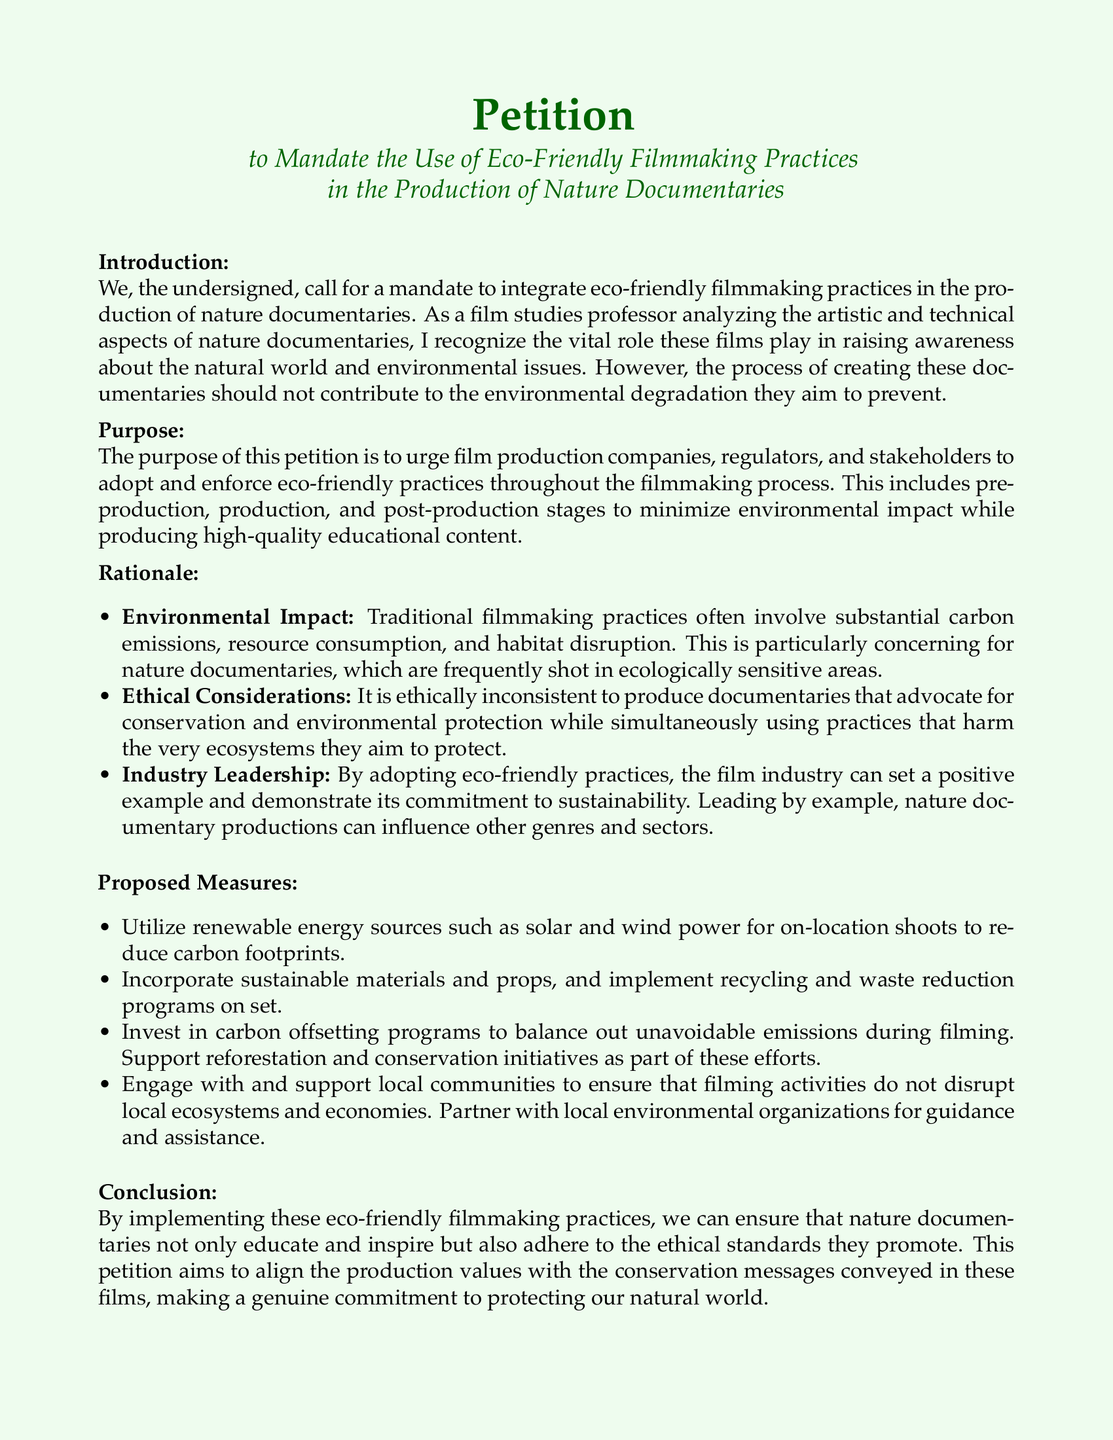What is the title of the petition? The title is explicitly stated at the beginning of the document and identifies the main purpose of the petition.
Answer: Petition to Mandate the Use of Eco-Friendly Filmmaking Practices in the Production of Nature Documentaries Who is the author of the petition? The author is indicated at the bottom of the document where the signature line is provided.
Answer: Film Studies Professor What is one goal of the petition? The purpose of the petition clearly outlines the main goal regarding filmmaking practices, as explained in the document.
Answer: Urge film production companies to adopt and enforce eco-friendly practices List one proposed eco-friendly measure. The document lists specific measures to implement eco-friendly practices, which can be found under the proposed measures section.
Answer: Utilize renewable energy sources What is a key ethical concern mentioned in the petition? The rationale section highlights ethical considerations in filmmaking, drawing attention to contradictions within documentary production practices.
Answer: Ethical inconsistency How does the petition propose to offset emissions? The document explains proposed measures that include methods for balancing emissions, which are detailed in the corresponding section.
Answer: Invest in carbon offsetting programs What is the primary target audience of the petition? The call to action specifies who the petition is directed toward, focusing on key stakeholders in the filmmaking process.
Answer: Policymakers, production companies, and stakeholders What color is used for the title text? The document visually describes the color scheme utilized for key sections, including the title.
Answer: Dark green 